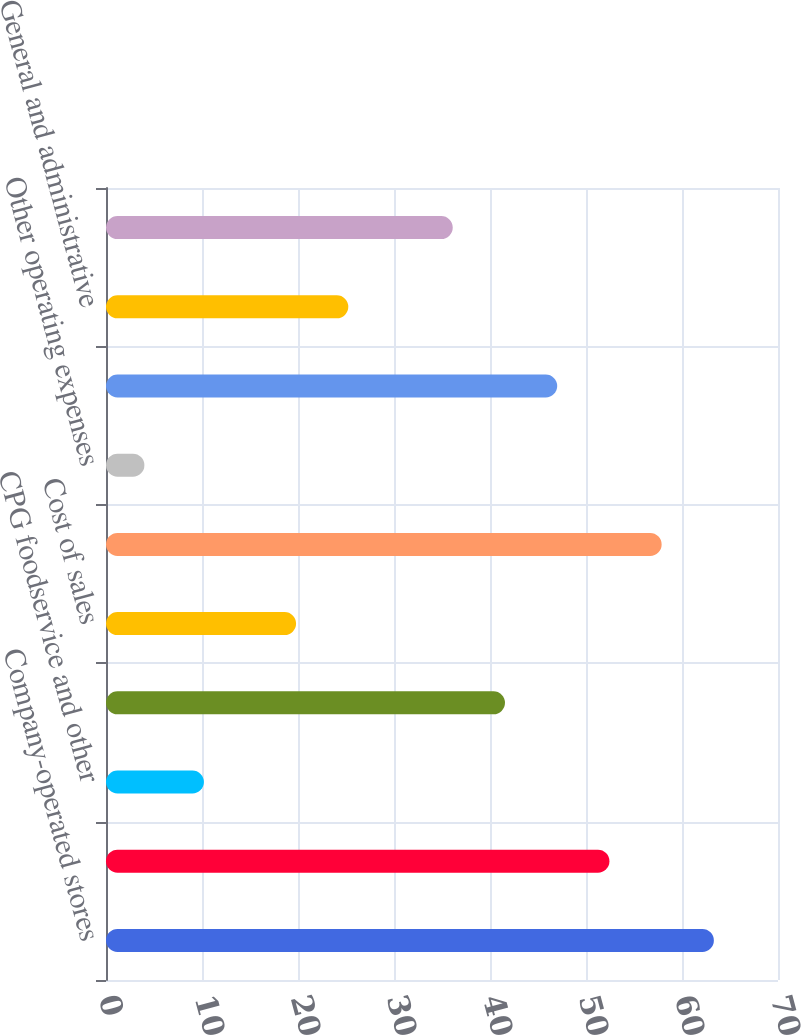<chart> <loc_0><loc_0><loc_500><loc_500><bar_chart><fcel>Company-operated stores<fcel>Licensed stores<fcel>CPG foodservice and other<fcel>Total net revenues<fcel>Cost of sales<fcel>Store operating expenses<fcel>Other operating expenses<fcel>Depreciation and amortization<fcel>General and administrative<fcel>Total operating expenses<nl><fcel>63.32<fcel>52.44<fcel>10.2<fcel>41.56<fcel>19.8<fcel>57.88<fcel>4<fcel>47<fcel>25.24<fcel>36.12<nl></chart> 